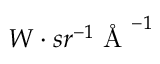Convert formula to latex. <formula><loc_0><loc_0><loc_500><loc_500>W \cdot s r ^ { - 1 } \ r { A } ^ { - 1 }</formula> 